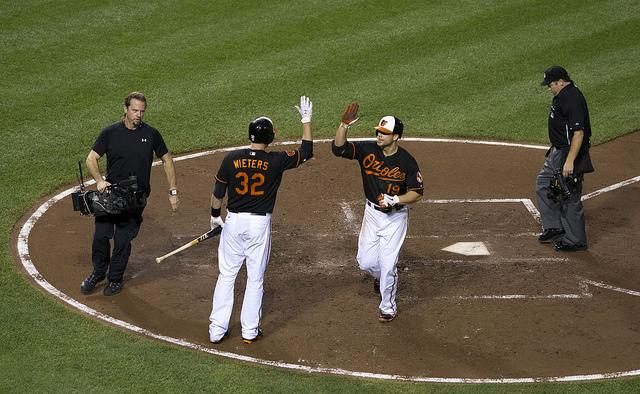Where did 19 just step away from? home plate 